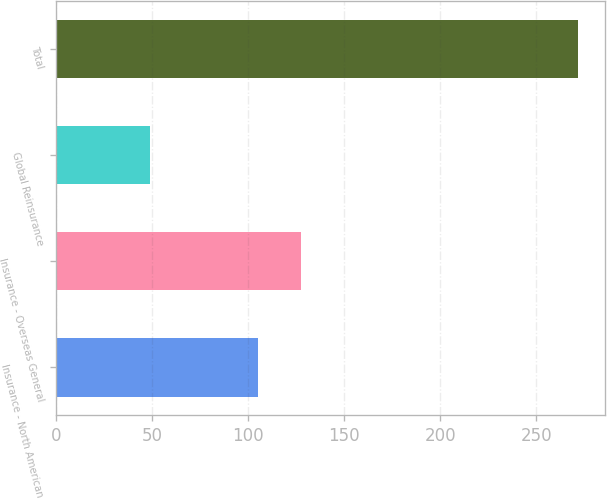<chart> <loc_0><loc_0><loc_500><loc_500><bar_chart><fcel>Insurance - North American<fcel>Insurance - Overseas General<fcel>Global Reinsurance<fcel>Total<nl><fcel>105<fcel>127.3<fcel>49<fcel>272<nl></chart> 